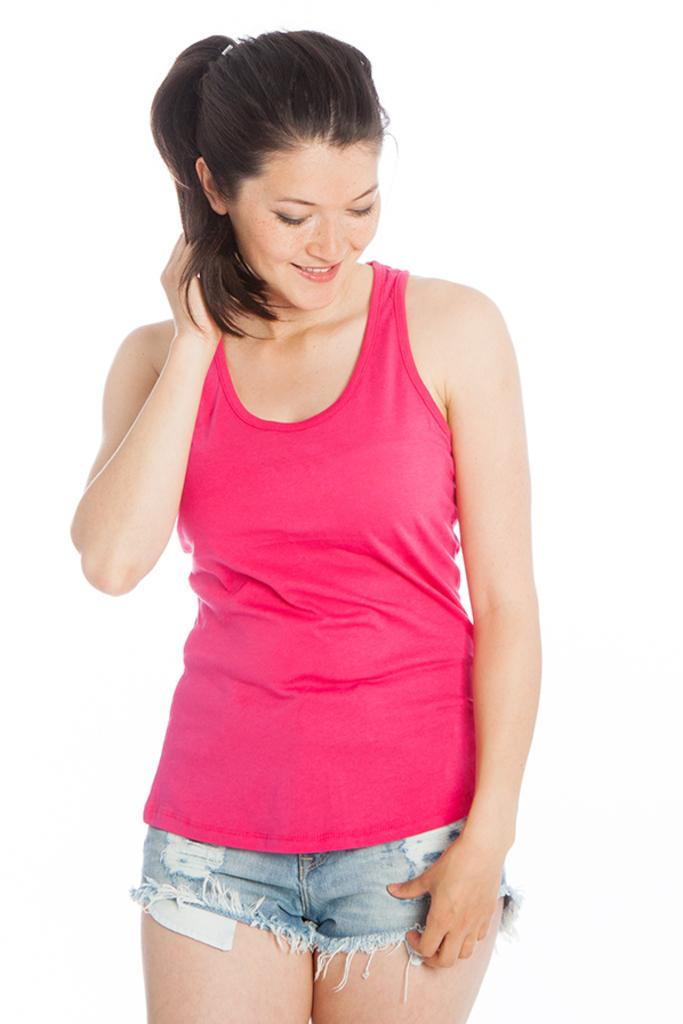Who is the main subject in the image? There is a woman in the image. What is the woman doing in the image? The woman is standing and smiling. What can be seen in the background of the image? The background of the image is white. What type of lace is the woman wearing in the image? There is no lace visible in the image. How does the woman react to the summer heat in the image? The image does not provide any information about the weather or the woman's reaction to it. 